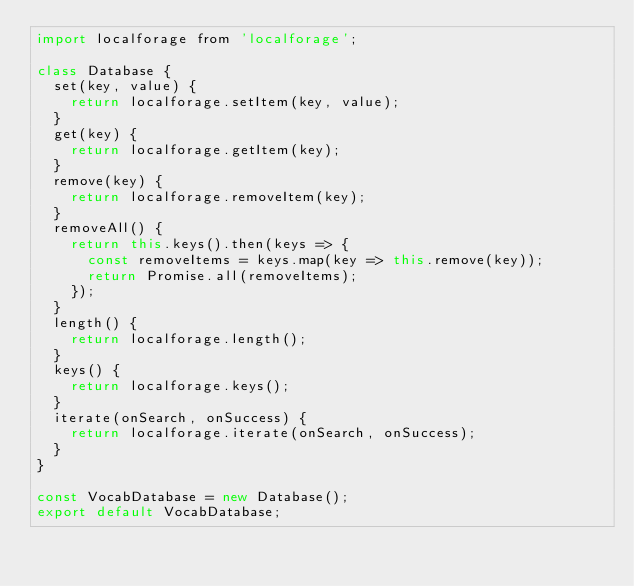<code> <loc_0><loc_0><loc_500><loc_500><_JavaScript_>import localforage from 'localforage';

class Database {
	set(key, value) {
		return localforage.setItem(key, value);
	}
	get(key) {
		return localforage.getItem(key);
	}
	remove(key) {
		return localforage.removeItem(key);
	}
	removeAll() {
		return this.keys().then(keys => {
			const removeItems = keys.map(key => this.remove(key));
			return Promise.all(removeItems);
		});
	}
	length() {
		return localforage.length();
	}
	keys() {
		return localforage.keys();
	}
	iterate(onSearch, onSuccess) {
		return localforage.iterate(onSearch, onSuccess);
	}
}

const VocabDatabase = new Database();
export default VocabDatabase;</code> 